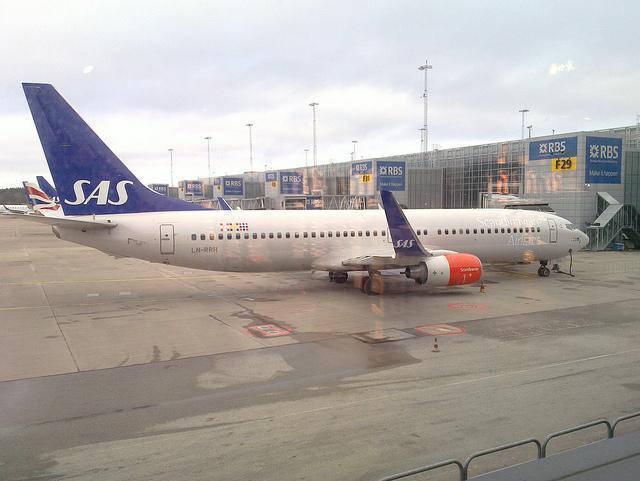What country is served by this airline?
Make your selection from the four choices given to correctly answer the question.
Options: China, egypt, sweden, netherlands. Sweden. 